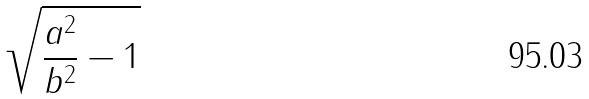<formula> <loc_0><loc_0><loc_500><loc_500>\sqrt { \frac { a ^ { 2 } } { b ^ { 2 } } - 1 }</formula> 